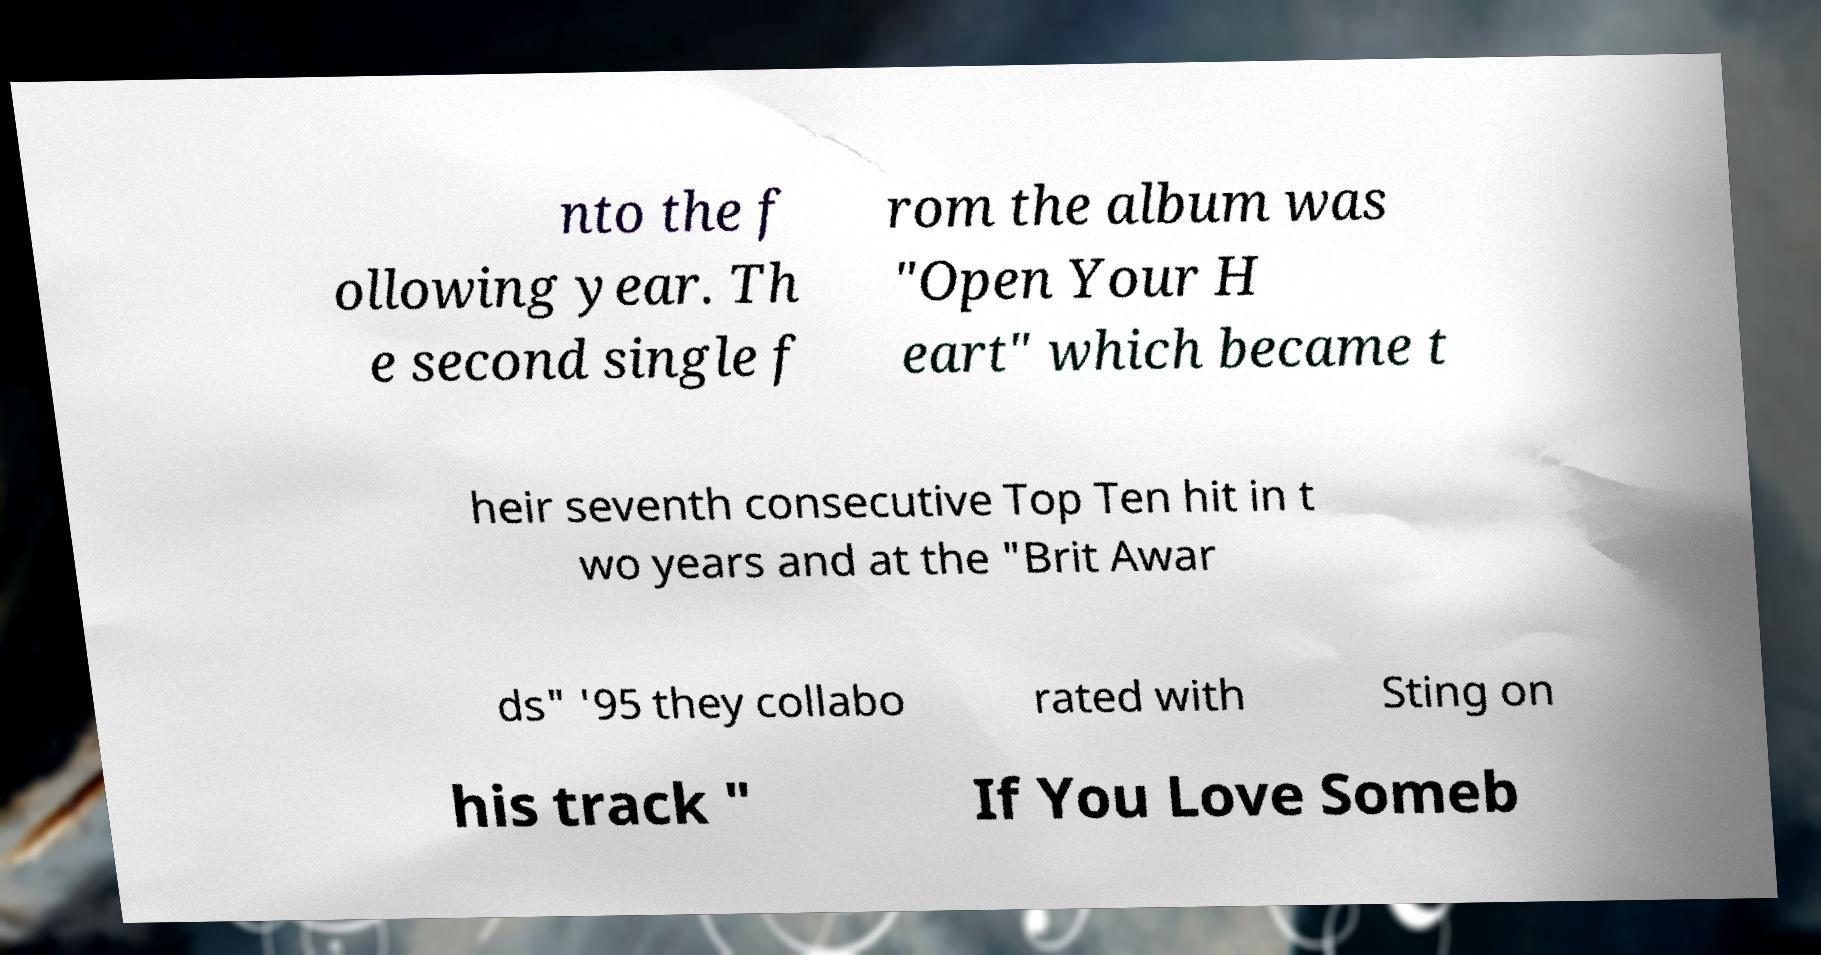Can you accurately transcribe the text from the provided image for me? nto the f ollowing year. Th e second single f rom the album was "Open Your H eart" which became t heir seventh consecutive Top Ten hit in t wo years and at the "Brit Awar ds" '95 they collabo rated with Sting on his track " If You Love Someb 